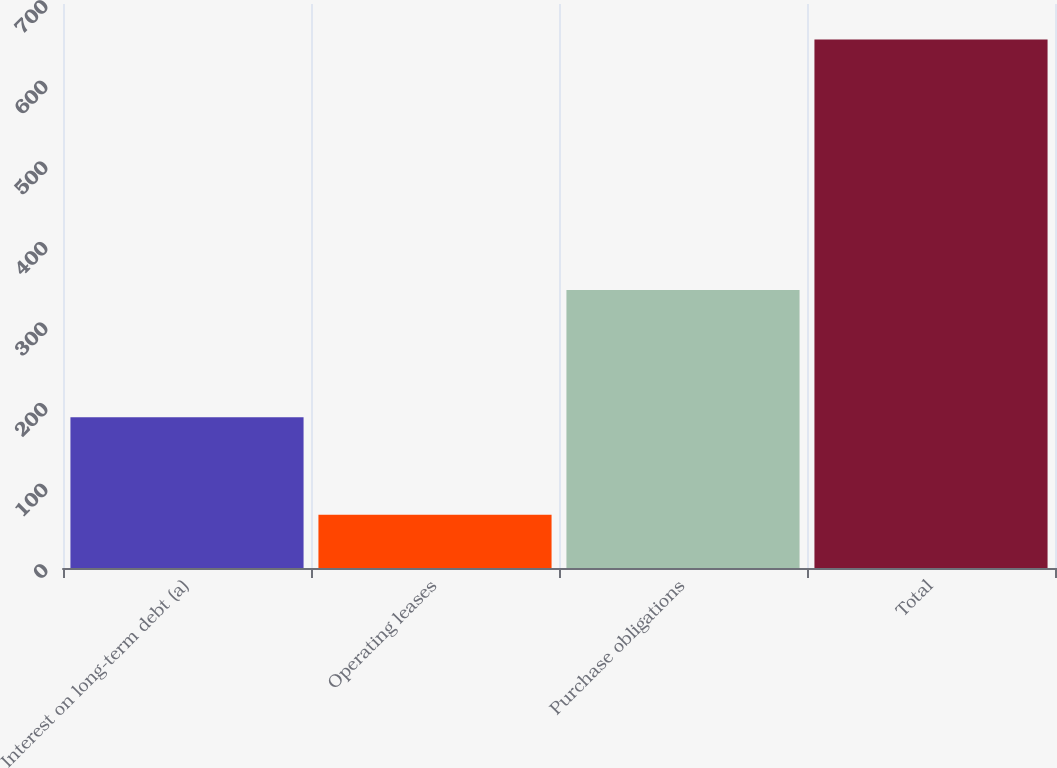Convert chart to OTSL. <chart><loc_0><loc_0><loc_500><loc_500><bar_chart><fcel>Interest on long-term debt (a)<fcel>Operating leases<fcel>Purchase obligations<fcel>Total<nl><fcel>187<fcel>66<fcel>345<fcel>656<nl></chart> 